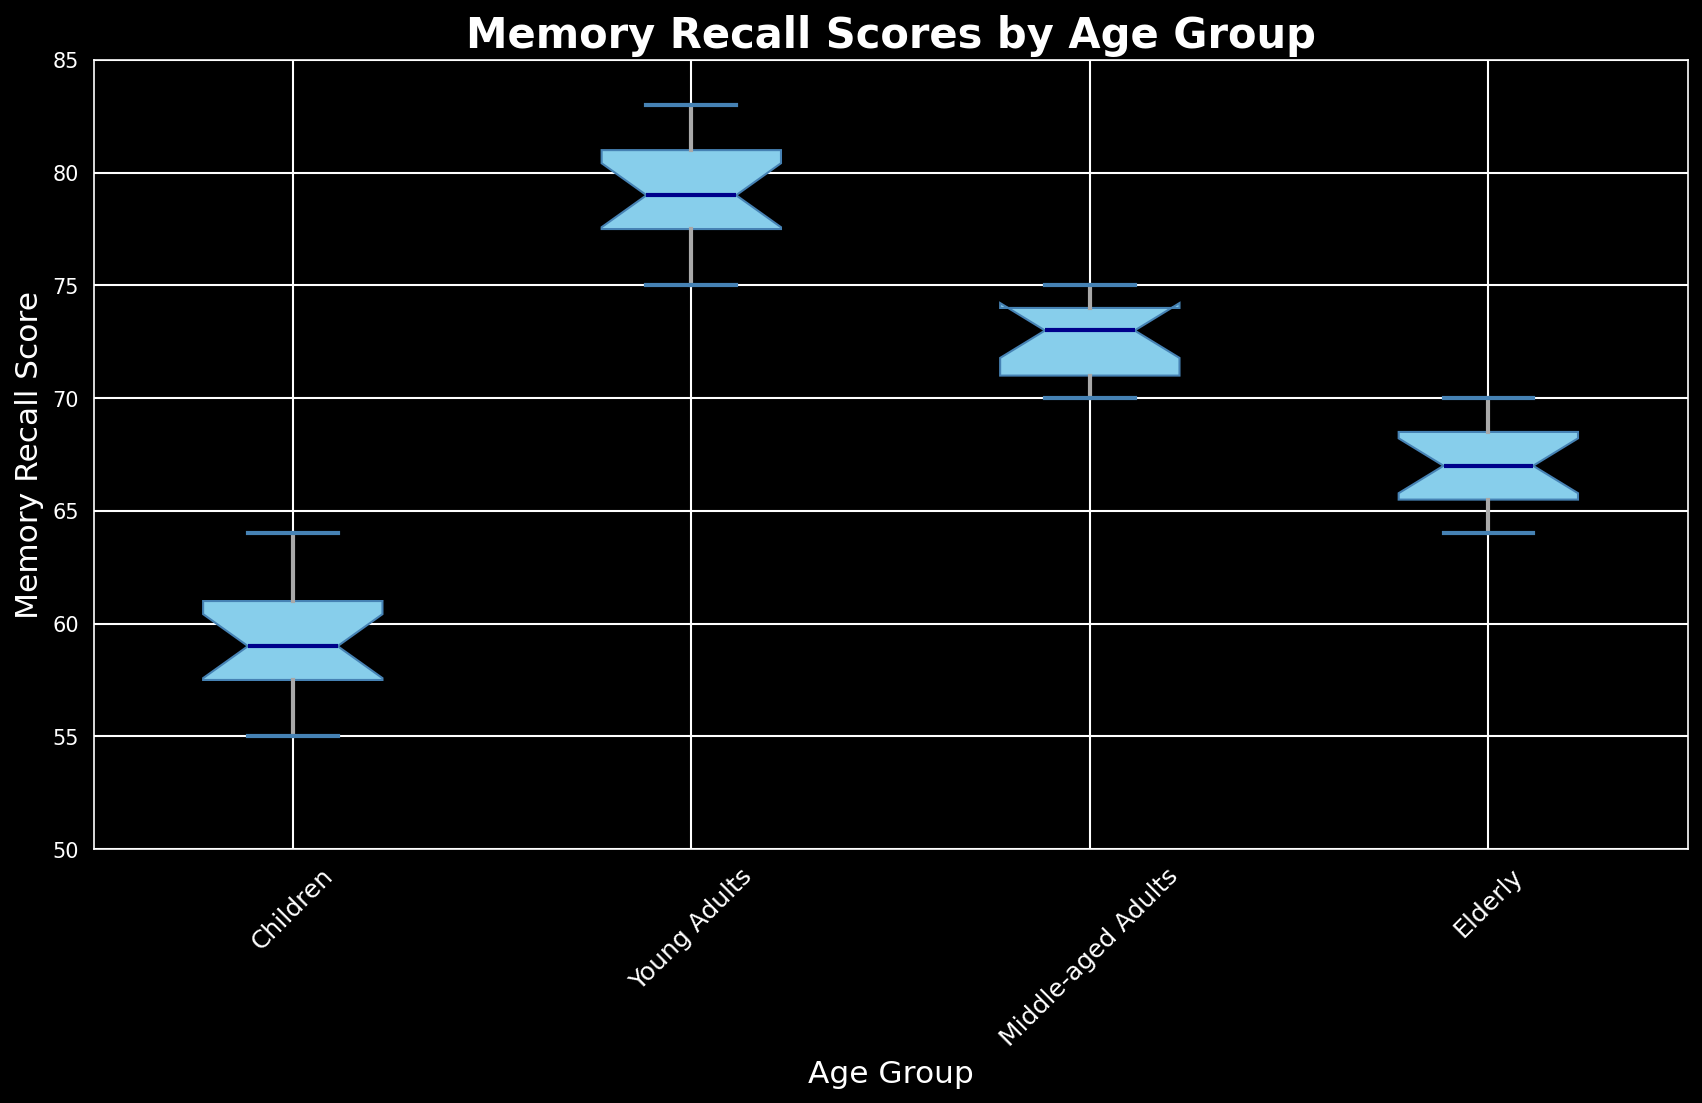What is the median Memory Recall Score for Young Adults? The median is the middle value of the dataset. For Young Adults, the sorted scores are [75, 76, 77, 77, 78, 78, 79, 79, 80, 80, 81, 81, 82, 82, 83]. The middle value in this sorted list is the 8th value, which is 79.
Answer: 79 Which age group has the highest median Memory Recall Score? To determine the group with the highest median, compare the median scores of all groups: Children, Young Adults, Middle-aged Adults, and Elderly. The median scores are 59, 79, 73, and 66, respectively. The highest among these is Young Adults with 79.
Answer: Young Adults What are the third quartile (Q3) values for children and elderly groups? The third quartile (Q3) is the median of the upper half of the dataset. For Children, sorted scores are [55, 56, 57, 57, 58, 58, 59, 59, 60, 60, 61, 61, 62, 63, 64]. Q3 is the average of the 12th and 13th values, which is (61 + 62) / 2 = 61.5. For Elderly, sorted scores are [64, 64, 65, 65, 66, 66, 66, 67, 67, 68, 68, 69, 69, 70, 70]. Q3 is the average of the 12th and 13th values, which is (69 + 69) / 2 = 69.
Answer: Children: 61.5, Elderly: 69 How does the interquartile range (IQR) of Middle-aged Adults compare to Young Adults? The IQR is calculated by subtracting the first quartile (Q1) from the third quartile (Q3). For Middle-aged Adults, Q1 is 71 and Q3 is 74, so IQR is 74 - 71 = 3. For Young Adults, Q1 is 77 and Q3 is 81, so IQR is 81 - 77 = 4. Comparing the IQRs, Young Adults have a higher IQR (4) than Middle-aged Adults (3).
Answer: Young Adults' IQR is higher Which group has the smallest range of Memory Recall Scores? The range is the difference between the maximum and minimum values in the dataset. For Children: 64 - 55 = 9, Young Adults: 83 - 75 = 8, Middle-aged Adults: 75 - 70 = 5, and Elderly: 70 - 64 = 6. The smallest range is observed in Middle-aged Adults with a range of 5.
Answer: Middle-aged Adults Are there any outliers in the Memory Recall Scores of any groups? In a box plot, outliers are typically indicated by points that fall outside the whiskers. Based on the box plot's visual information, there are no outliers in any of the age groups since no individual points are marked separately from the whiskers and boxes.
Answer: No Which age group has the widest spread of Memory Recall Scores? The spread is determined by the range of the box plot's whiskers. Comparing the visual lengths of the whiskers, Children have the widest spread ranging from roughly 55 to 64, showing a broader distribution of scores.
Answer: Children What is the median Memory Recall Score for Middle-aged Adults? The median is the middle value. For Middle-aged Adults, the sorted scores are [70, 70, 71, 71, 71, 72, 72, 73, 73, 73, 74, 74, 74, 75, 75]. The middle value in this sorted list is 73.
Answer: 73 How would you describe the overall trend in Memory Recall Scores across the age groups? Observing the medians across the groups, the scores tend to increase from Children to Young Adults, then slightly decrease for Middle-aged Adults, and decrease further for Elderly. Young Adults have the highest median, followed by Middle-aged Adults, Elderly, and Children in ascending order.
Answer: Increases to Young Adults, then declines Which group has the highest variability in Memory Recall Scores? Variability can be assessed by observing both the range and the spread of the box plot. Children have the highest variability as indicated by the length of the whiskers, showing a wider range of scores compared to other groups.
Answer: Children 